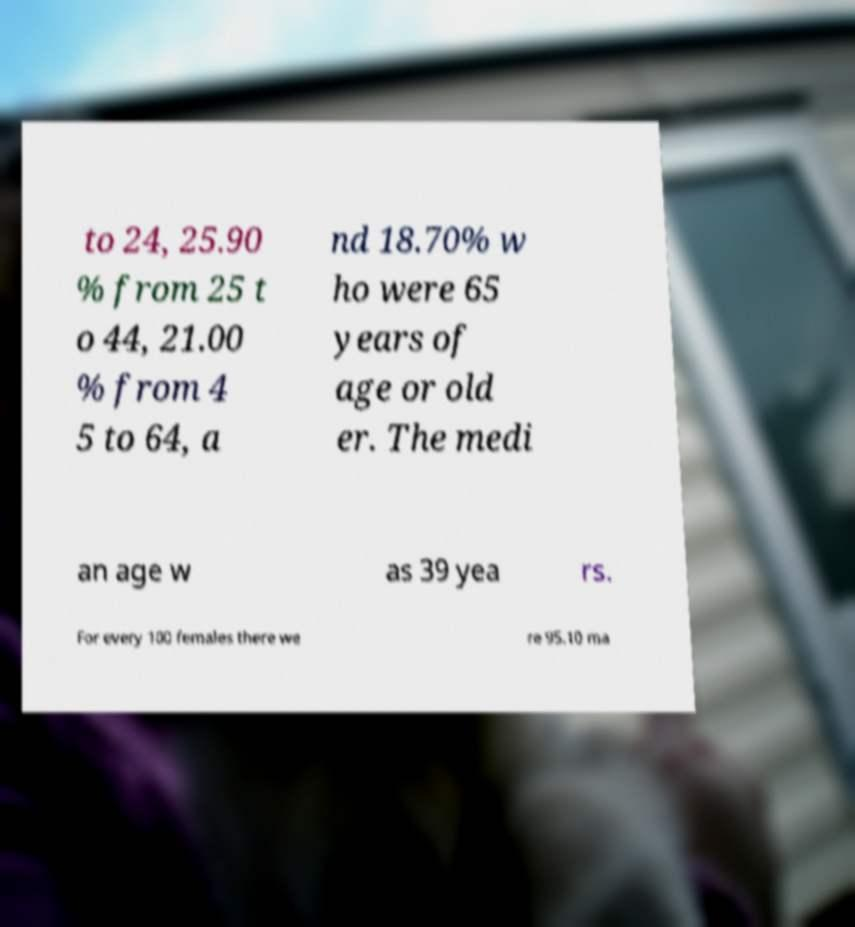What messages or text are displayed in this image? I need them in a readable, typed format. to 24, 25.90 % from 25 t o 44, 21.00 % from 4 5 to 64, a nd 18.70% w ho were 65 years of age or old er. The medi an age w as 39 yea rs. For every 100 females there we re 95.10 ma 